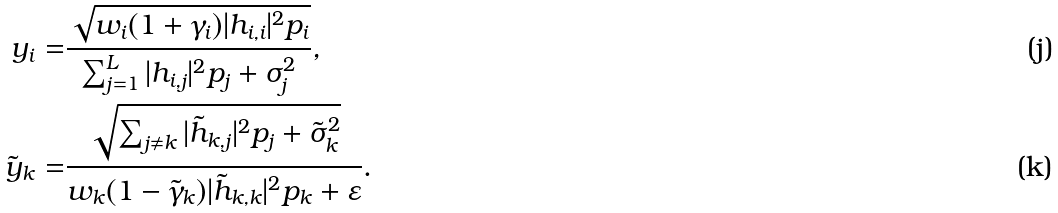Convert formula to latex. <formula><loc_0><loc_0><loc_500><loc_500>y _ { i } = & \frac { \sqrt { w _ { i } ( 1 + \gamma _ { i } ) | h _ { i , i } | ^ { 2 } p _ { i } } } { \sum _ { j = 1 } ^ { L } | h _ { i , j } | ^ { 2 } p _ { j } + \sigma ^ { 2 } _ { j } } , \\ \tilde { y } _ { k } = & \frac { \sqrt { \sum _ { j \ne k } | \tilde { h } _ { k , j } | ^ { 2 } p _ { j } + \tilde { \sigma } ^ { 2 } _ { k } } } { w _ { k } ( 1 - \tilde { \gamma } _ { k } ) | \tilde { h } _ { k , k } | ^ { 2 } p _ { k } + \varepsilon } .</formula> 